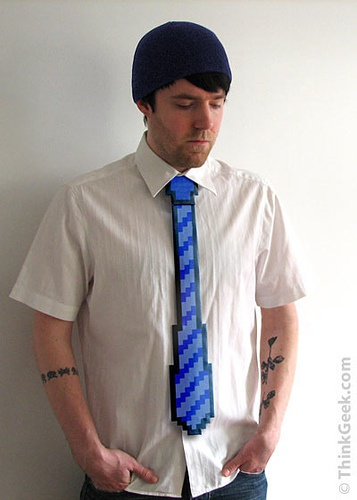Describe the objects in this image and their specific colors. I can see people in darkgray, lightgray, and gray tones and tie in darkgray, gray, black, darkblue, and blue tones in this image. 